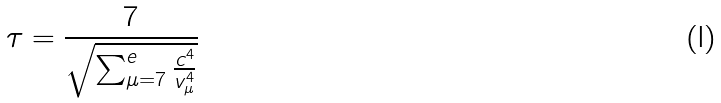Convert formula to latex. <formula><loc_0><loc_0><loc_500><loc_500>\tau = \frac { 7 } { \sqrt { \sum _ { \mu = 7 } ^ { e } \frac { c ^ { 4 } } { v _ { \mu } ^ { 4 } } } }</formula> 